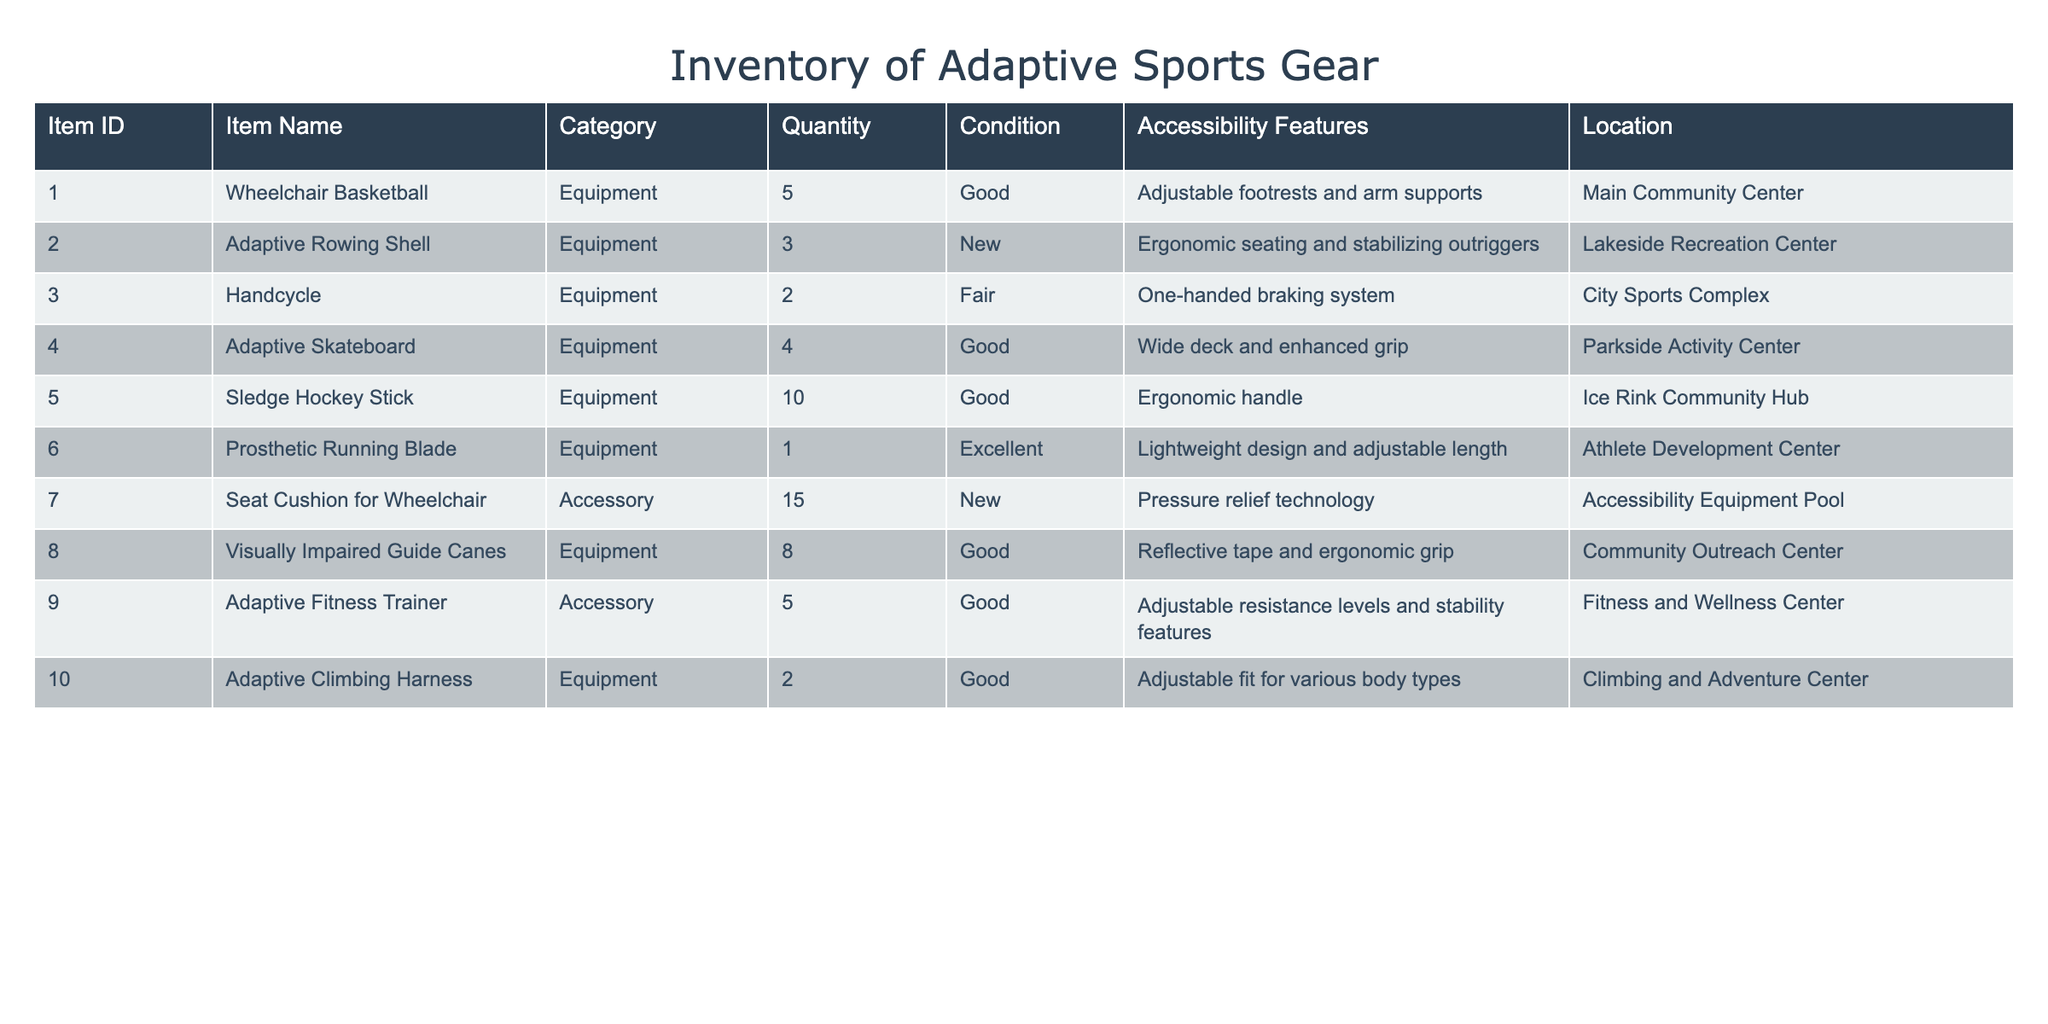What is the total quantity of adaptive sports gear available? To find the total quantity of adaptive sports gear, we add up the quantity from all rows: 5 + 3 + 2 + 4 + 10 + 1 + 15 + 8 + 5 + 2 = 50.
Answer: 50 Which item has the largest quantity? By inspecting the quantity column, the item with the largest quantity is the Sledge Hockey Stick with a quantity of 10.
Answer: Sledge Hockey Stick Are all items in good or excellent condition? Checking the condition column, we see that there is one item listed as fair, the Handcycle. Therefore, not all items are in good or excellent condition.
Answer: No What is the average quantity of Equipment items available? First, we check the number of Equipment items, which are 7 (from rows 1 to 6 and 10). Their quantities are 5, 3, 2, 4, 10, 1, and 2, summing to 27. The average is 27/7 = 3.86.
Answer: 3.86 How many items have accessibility features specifically for visually impaired users? In the table, there is one item designed for visually impaired users, which are the Visually Impaired Guide Canes.
Answer: 1 What is the total number of Accessories available? There are two Accessories listed in the table: Seat Cushion for Wheelchair (15) and Adaptive Fitness Trainer (5). Their total is 15 + 5 = 20.
Answer: 20 Can you list the locations where the equipment is available? The items listed are distributed among 6 locations: Main Community Center, Lakeside Recreation Center, City Sports Complex, Parkside Activity Center, Ice Rink Community Hub, Athlete Development Center, Accessibility Equipment Pool, Community Outreach Center, and Climbing and Adventure Center.
Answer: 9 locations How many items have adjustable features in their accessibility features? The items with adjustable features are Wheelchair Basketball, Prosthetic Running Blade, Adaptive Fitness Trainer, and Adaptive Climbing Harness, totaling 4 items.
Answer: 4 Which equipment has the least quantity, and what is its condition? The item with the least quantity is the Prosthetic Running Blade with a quantity of 1, and it is in excellent condition.
Answer: Prosthetic Running Blade; Excellent 